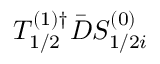<formula> <loc_0><loc_0><loc_500><loc_500>T _ { 1 / 2 } ^ { ( 1 ) \dagger } \bar { D } S _ { 1 / 2 i } ^ { ( 0 ) }</formula> 